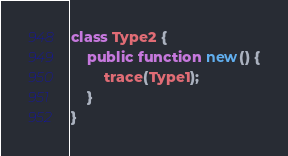Convert code to text. <code><loc_0><loc_0><loc_500><loc_500><_Haxe_>class Type2 {
	public function new() {
		trace(Type1);
	}
}</code> 